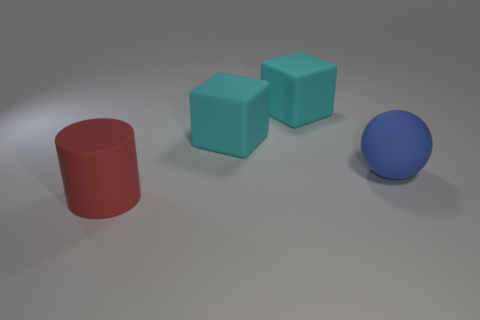Add 4 brown matte balls. How many objects exist? 8 Subtract all spheres. How many objects are left? 3 Subtract 1 red cylinders. How many objects are left? 3 Subtract all large matte balls. Subtract all big cyan rubber things. How many objects are left? 1 Add 2 big cylinders. How many big cylinders are left? 3 Add 4 big cyan matte objects. How many big cyan matte objects exist? 6 